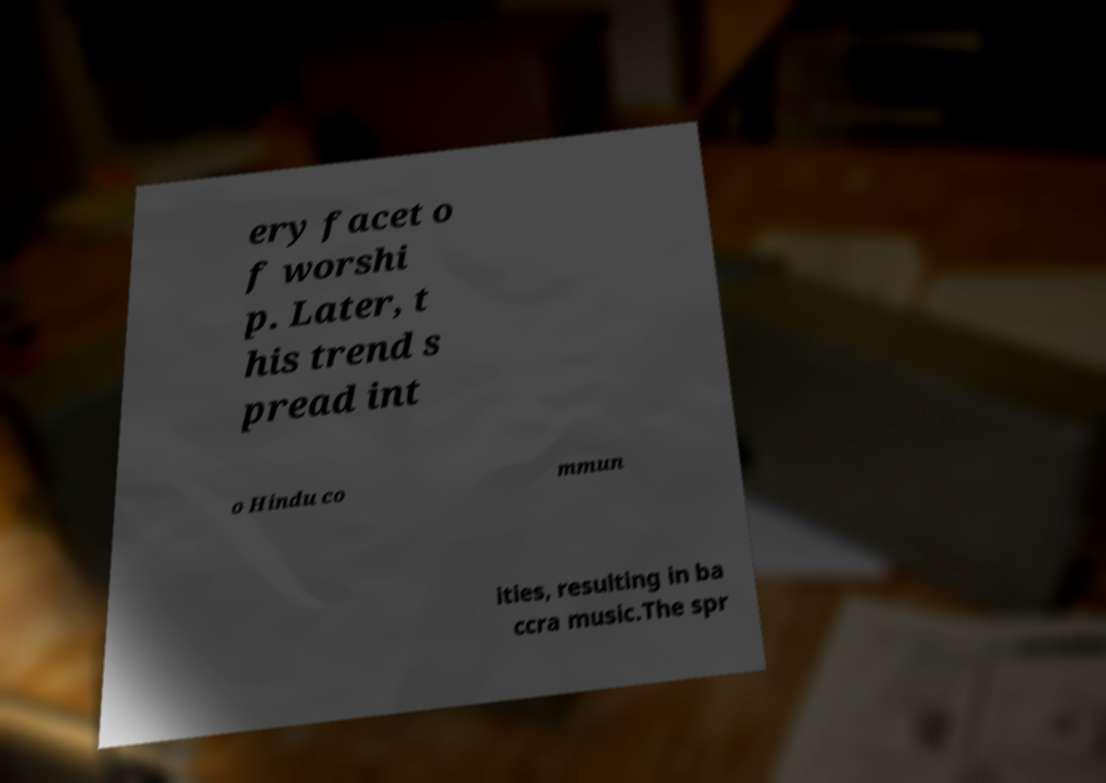Please identify and transcribe the text found in this image. ery facet o f worshi p. Later, t his trend s pread int o Hindu co mmun ities, resulting in ba ccra music.The spr 